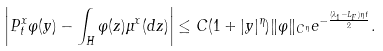Convert formula to latex. <formula><loc_0><loc_0><loc_500><loc_500>\left | P ^ { x } _ { t } \varphi ( y ) - \int _ { H } \varphi ( z ) \mu ^ { x } ( d z ) \right | \leq C ( 1 + | y | ^ { \eta } ) \| \varphi \| _ { C ^ { \eta } } e ^ { - \frac { ( \lambda _ { 1 } - L _ { F } ) \eta t } { 2 } } .</formula> 